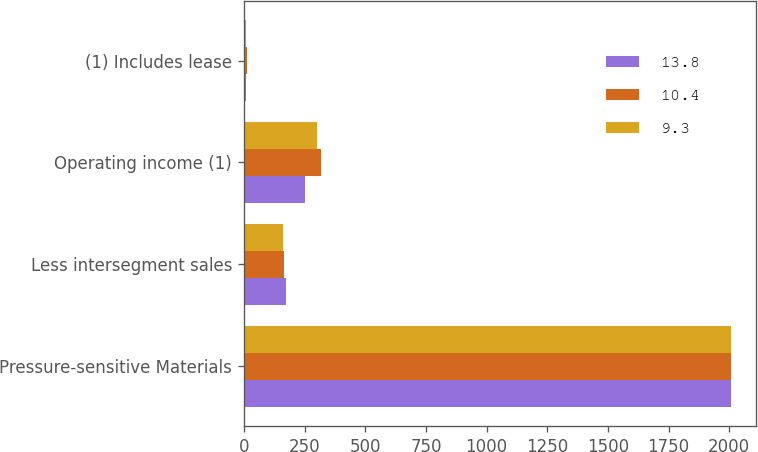Convert chart. <chart><loc_0><loc_0><loc_500><loc_500><stacked_bar_chart><ecel><fcel>Pressure-sensitive Materials<fcel>Less intersegment sales<fcel>Operating income (1)<fcel>(1) Includes lease<nl><fcel>13.8<fcel>2008<fcel>172.4<fcel>252.3<fcel>10.4<nl><fcel>10.4<fcel>2007<fcel>164.9<fcel>318.7<fcel>13.8<nl><fcel>9.3<fcel>2006<fcel>161.5<fcel>301.6<fcel>9.3<nl></chart> 